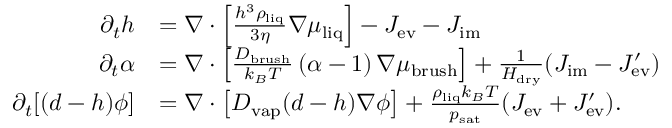<formula> <loc_0><loc_0><loc_500><loc_500>\begin{array} { r l } { \partial _ { t } h } & { = \nabla \cdot \left [ \frac { h ^ { 3 } \rho _ { l i q } } { 3 \eta } \nabla \mu _ { l i q } \right ] - J _ { e v } - J _ { i m } } \\ { \partial _ { t } \alpha } & { = \nabla \cdot \left [ \frac { D _ { b r u s h } } { k _ { B } T } \, ( \alpha - 1 ) \, \nabla \mu _ { b r u s h } \right ] + \frac { 1 } { H _ { d r y } } ( J _ { i m } - J _ { e v } ^ { \prime } ) } \\ { \partial _ { t } [ ( d - h ) \phi ] } & { = \nabla \cdot \left [ D _ { v a p } ( d - h ) \nabla \phi \right ] + \frac { \rho _ { l i q } k _ { B } T } { p _ { s a t } } ( J _ { e v } + J _ { e v } ^ { \prime } ) . } \end{array}</formula> 